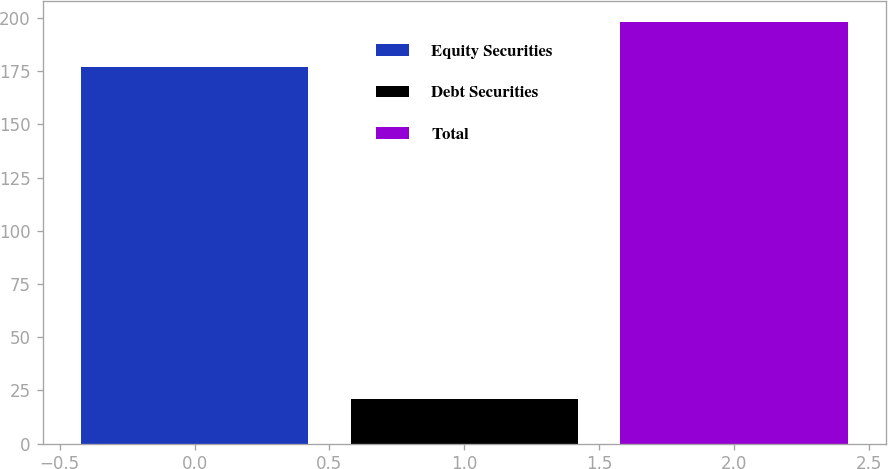Convert chart to OTSL. <chart><loc_0><loc_0><loc_500><loc_500><bar_chart><fcel>Equity Securities<fcel>Debt Securities<fcel>Total<nl><fcel>177<fcel>21<fcel>198<nl></chart> 